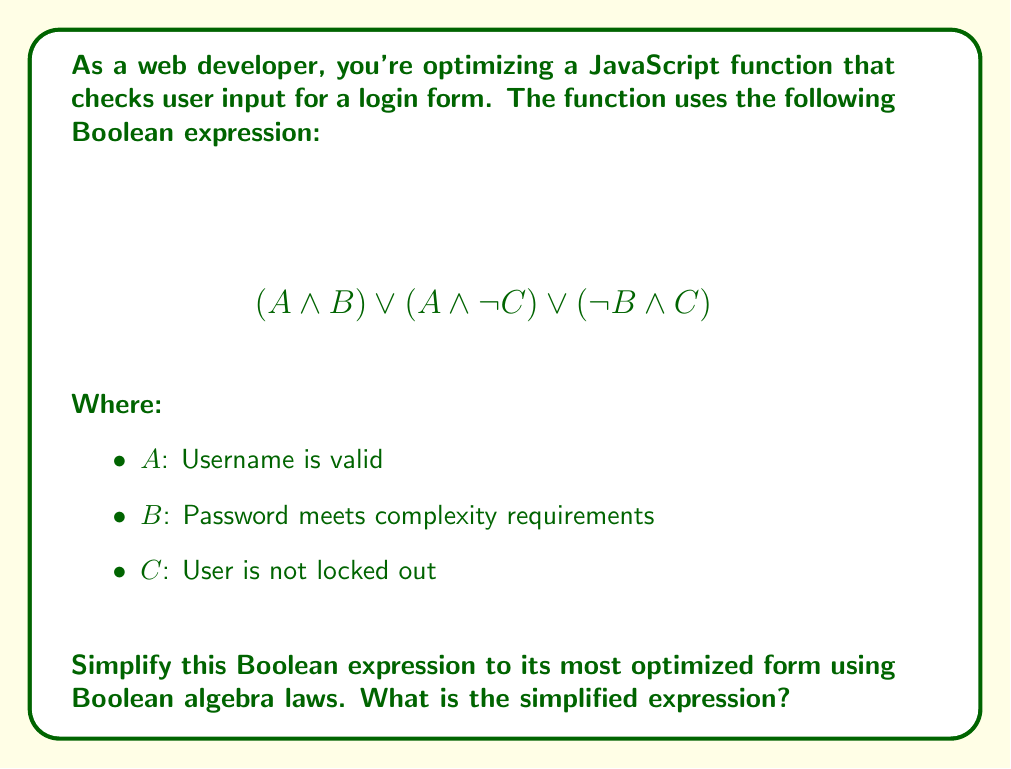Can you answer this question? Let's simplify the expression step by step using Boolean algebra laws:

1) Start with the original expression:
   $$(A \land B) \lor (A \land \lnot C) \lor (\lnot B \land C)$$

2) Apply the distributive law to factor out $A$:
   $$A \land (B \lor \lnot C) \lor (\lnot B \land C)$$

3) Focus on $(B \lor \lnot C) \lor (\lnot B \land C)$:
   This is in the form of $(X \lor Y) \lor (\lnot X \land Z)$, which simplifies to $X \lor Z$ (absorption law).
   Here, $X = B$, $Y = \lnot C$, and $Z = C$.

4) Apply this simplification:
   $$A \land (B \lor C) \lor (\lnot B \land C)$$

5) Now we have a form similar to $A \land X \lor (\lnot X \land Y)$, which simplifies to $A \lor Y$ (another form of absorption law).
   Here, $X = (B \lor C)$ and $Y = C$.

6) Apply this final simplification:
   $$A \lor C$$

This simplified form means the function will return true if the username is valid OR the user is not locked out.
Answer: $A \lor C$ 